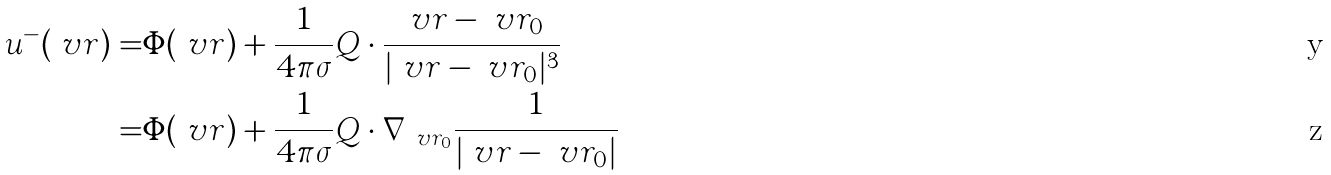<formula> <loc_0><loc_0><loc_500><loc_500>u ^ { - } ( \ v r ) = & \Phi ( \ v r ) + \frac { 1 } { 4 \pi \sigma } Q \cdot \frac { \ v r - \ v r _ { 0 } } { | \ v r - \ v r _ { 0 } | ^ { 3 } } \\ = & \Phi ( \ v r ) + \frac { 1 } { 4 \pi \sigma } Q \cdot \nabla _ { \ v r _ { 0 } } \frac { 1 } { | \ v r - \ v r _ { 0 } | }</formula> 